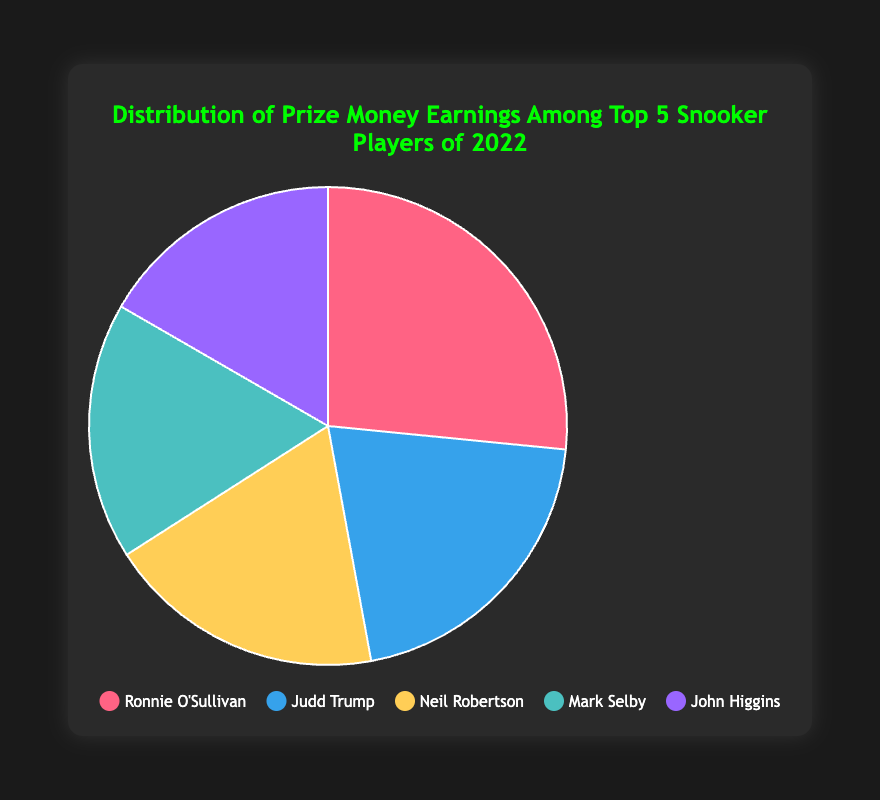Who earned the most prize money among the top 5 snooker players in 2022? The figure shows the distribution of prize money earnings with Ronnie O'Sullivan, Judd Trump, Neil Robertson, Mark Selby, and John Higgins. Among them, Ronnie O'Sullivan has the largest segment in the pie chart.
Answer: Ronnie O'Sullivan How much more did Ronnie O'Sullivan earn in comparison to John Higgins in 2022? Ronnie O'Sullivan earned £1,100,000 and John Higgins earned £690,000. Subtracting Higgins' earnings from O'Sullivan's gives £1,100,000 - £690,000 = £410,000.
Answer: £410,000 Which two players have the closest earnings? By looking at the segments, Neil Robertson and Mark Selby have notably close segments. Neil Robertson earned £780,000 and Mark Selby earned £720,000, giving a difference of £780,000 - £720,000 = £60,000, which is the smallest difference among the earnings of the players.
Answer: Neil Robertson and Mark Selby What is the total prize money earned by the top 5 snooker players in 2022 as shown in the chart? Summing up all the earnings: £1,100,000 (Ronnie O'Sullivan) + £850,000 (Judd Trump) + £780,000 (Neil Robertson) + £720,000 (Mark Selby) + £690,000 (John Higgins). The total is £1,100,000 + £850,000 + £780,000 + £720,000 + £690,000 = £4,140,000.
Answer: £4,140,000 Who earned less prize money than Judd Trump but more than Mark Selby? Judd Trump's earnings are £850,000, Mark Selby's are £720,000. Neil Robertson's earnings are £780,000, which is between these two figures.
Answer: Neil Robertson What percentage of the total earnings did Judd Trump make? Judd Trump's earnings were £850,000. The total earnings are £4,140,000. The percentage is calculated as (£850,000 / £4,140,000) * 100. The result is approximately 20.53%.
Answer: 20.53% What is the difference in prize money between the player who earned the second-highest and the player who earned the fourth-highest? The second-highest earner is Judd Trump with £850,000 and the fourth-highest earner is Mark Selby with £720,000. The difference is £850,000 - £720,000 = £130,000.
Answer: £130,000 Which player's earnings are represented by the green segment in the pie chart? The pie chart segment color for Neil Robertson is green. Referring to the player list, Neil Robertson's earnings are £780,000.
Answer: Neil Robertson What is the average earning of the top 5 snooker players in 2022? Summing the earnings of all players: £1,100,000 (Ronnie O'Sullivan) + £850,000 (Judd Trump) + £780,000 (Neil Robertson) + £720,000 (Mark Selby) + £690,000 (John Higgins) = £4,140,000. Dividing by the number of players: £4,140,000 / 5 = £828,000.
Answer: £828,000 